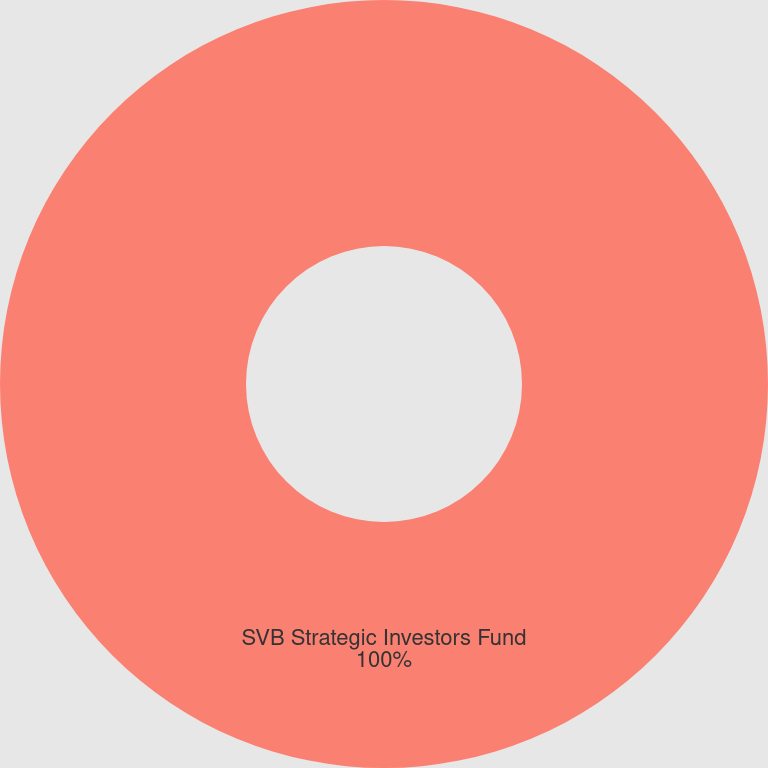Convert chart. <chart><loc_0><loc_0><loc_500><loc_500><pie_chart><fcel>SVB Strategic Investors Fund<nl><fcel>100.0%<nl></chart> 